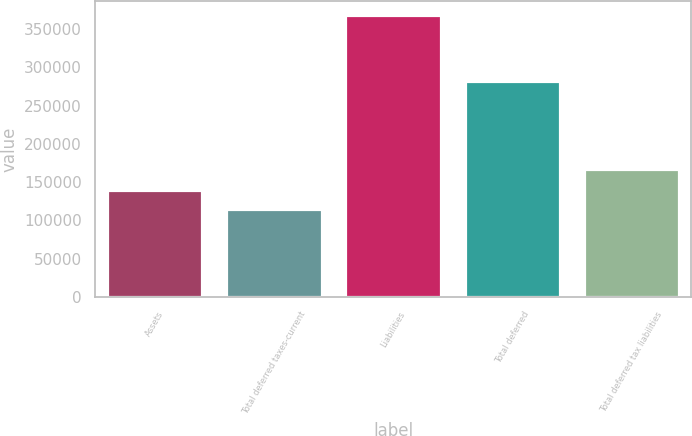Convert chart. <chart><loc_0><loc_0><loc_500><loc_500><bar_chart><fcel>Assets<fcel>Total deferred taxes-current<fcel>Liabilities<fcel>Total deferred<fcel>Total deferred tax liabilities<nl><fcel>139909<fcel>114565<fcel>368006<fcel>282214<fcel>167649<nl></chart> 